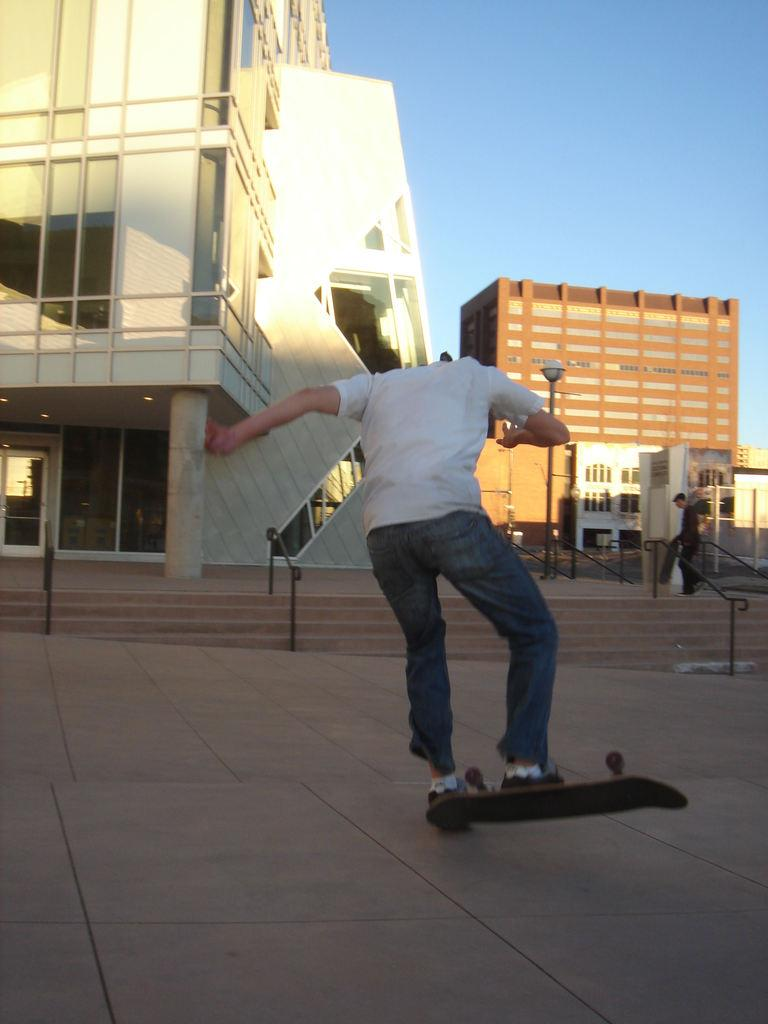What is the main activity of the person in the image? There is a person skating in the image. Can you describe any other activities happening in the background? There is a person walking in the background of the image. What type of structures can be seen in the image? There are buildings visible in the image. What objects are present in the image that might be used for support or guidance? There are poles and handrails on a staircase in the image. What is visible at the top of the image? The sky is visible at the top of the image. What type of cream can be seen on the locket in the image? There is no locket or cream present in the image. 